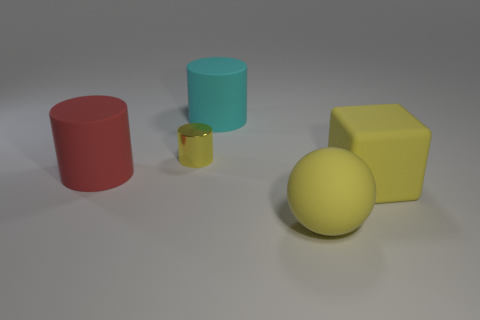How many things are either yellow matte cubes or yellow matte things?
Your response must be concise. 2. The matte block that is the same size as the red cylinder is what color?
Make the answer very short. Yellow. There is a cyan object; is it the same shape as the big rubber object to the left of the small yellow cylinder?
Offer a terse response. Yes. What number of things are either matte things on the right side of the yellow sphere or cylinders in front of the cyan cylinder?
Make the answer very short. 3. What is the shape of the tiny object that is the same color as the large cube?
Make the answer very short. Cylinder. The rubber thing to the right of the big matte ball has what shape?
Ensure brevity in your answer.  Cube. Is the shape of the large thing left of the cyan rubber thing the same as  the cyan matte object?
Provide a succinct answer. Yes. How many things are things that are to the left of the yellow ball or small blue spheres?
Ensure brevity in your answer.  3. What is the color of the small metallic thing that is the same shape as the big cyan matte object?
Your answer should be compact. Yellow. Is there anything else that has the same color as the small shiny cylinder?
Offer a terse response. Yes. 